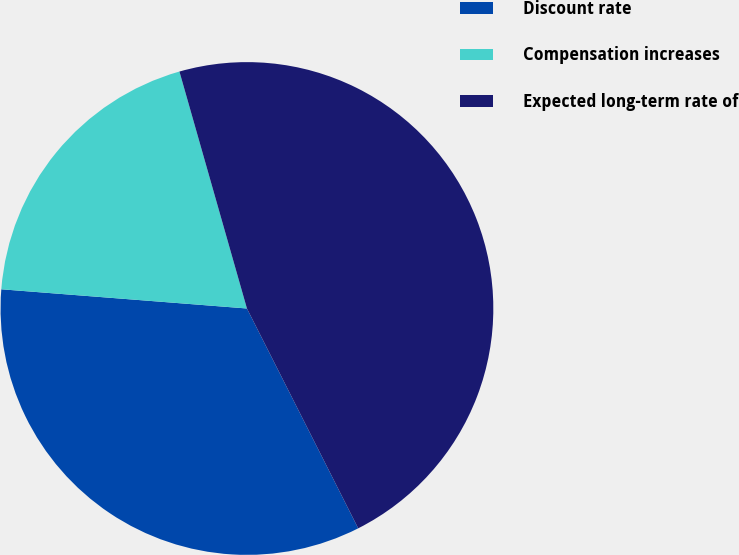<chart> <loc_0><loc_0><loc_500><loc_500><pie_chart><fcel>Discount rate<fcel>Compensation increases<fcel>Expected long-term rate of<nl><fcel>33.7%<fcel>19.34%<fcel>46.96%<nl></chart> 